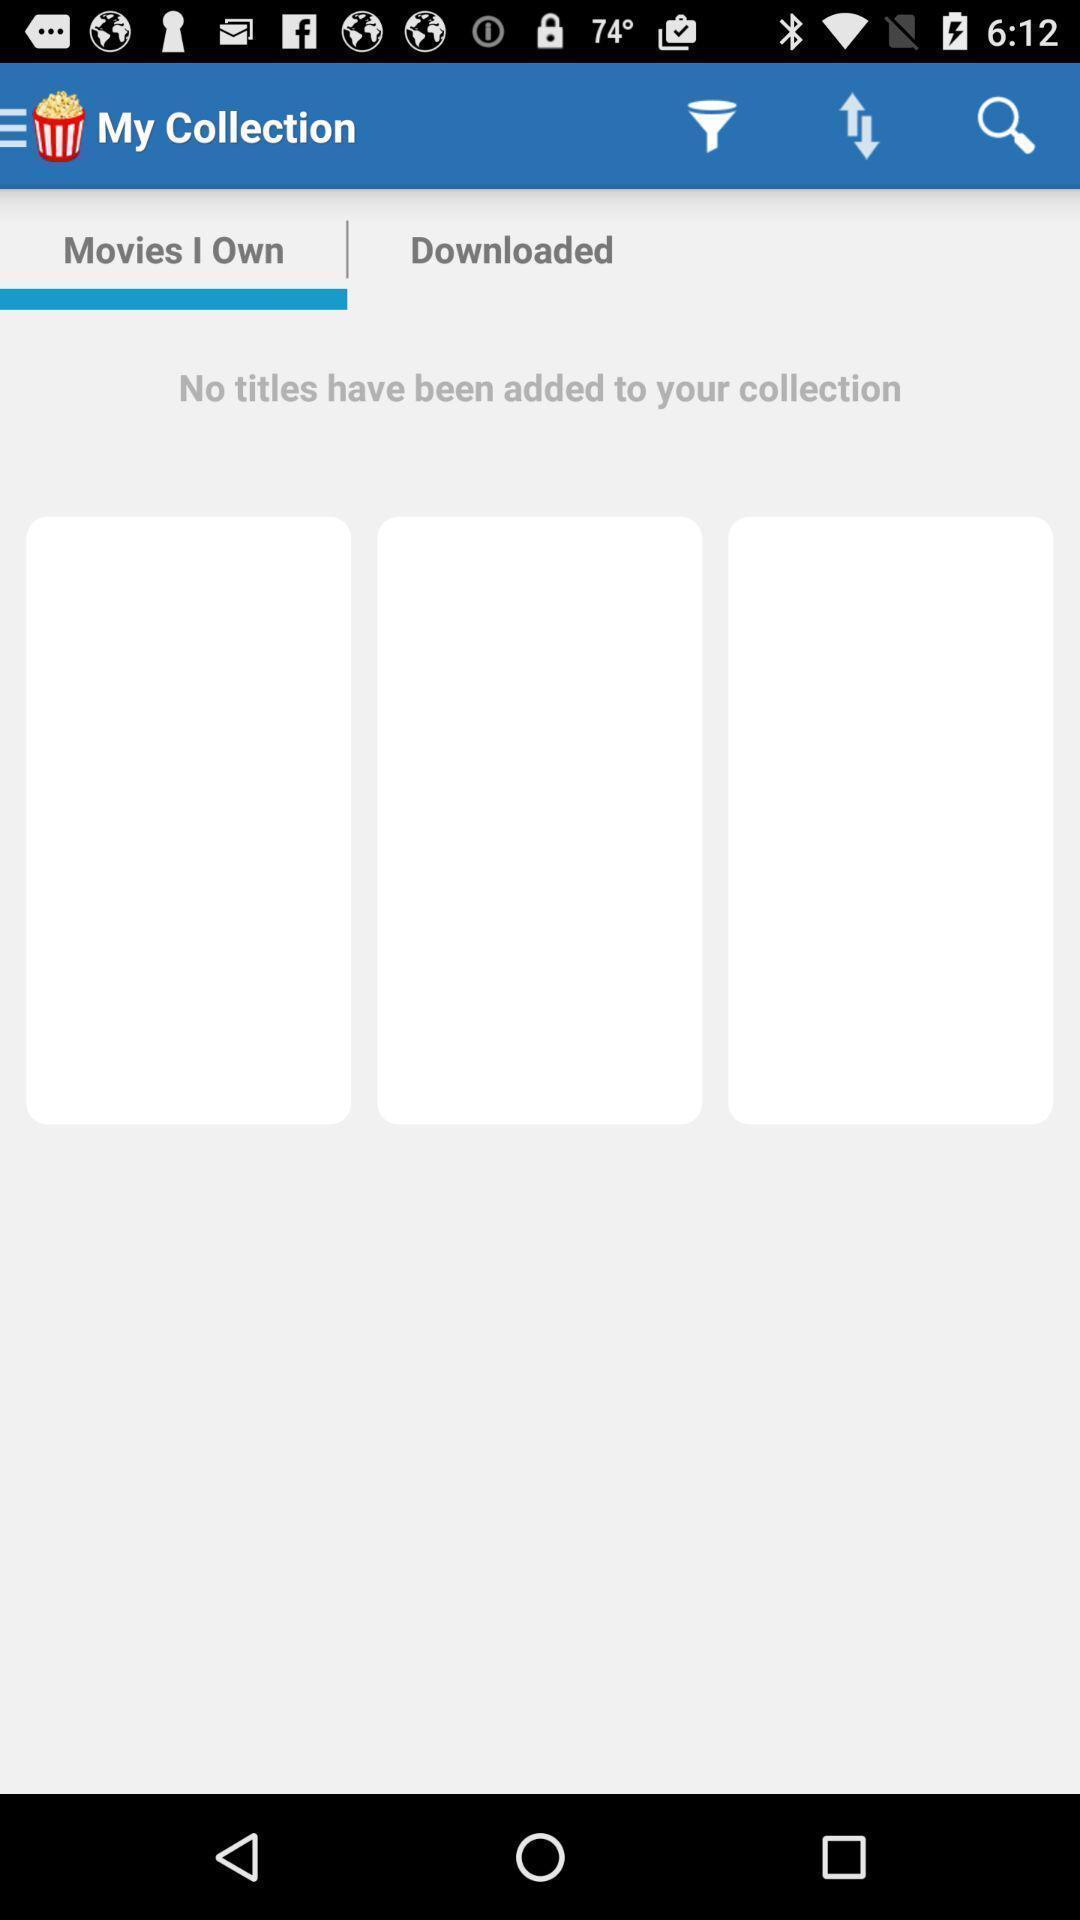Tell me about the visual elements in this screen capture. Search box with movies collection. 